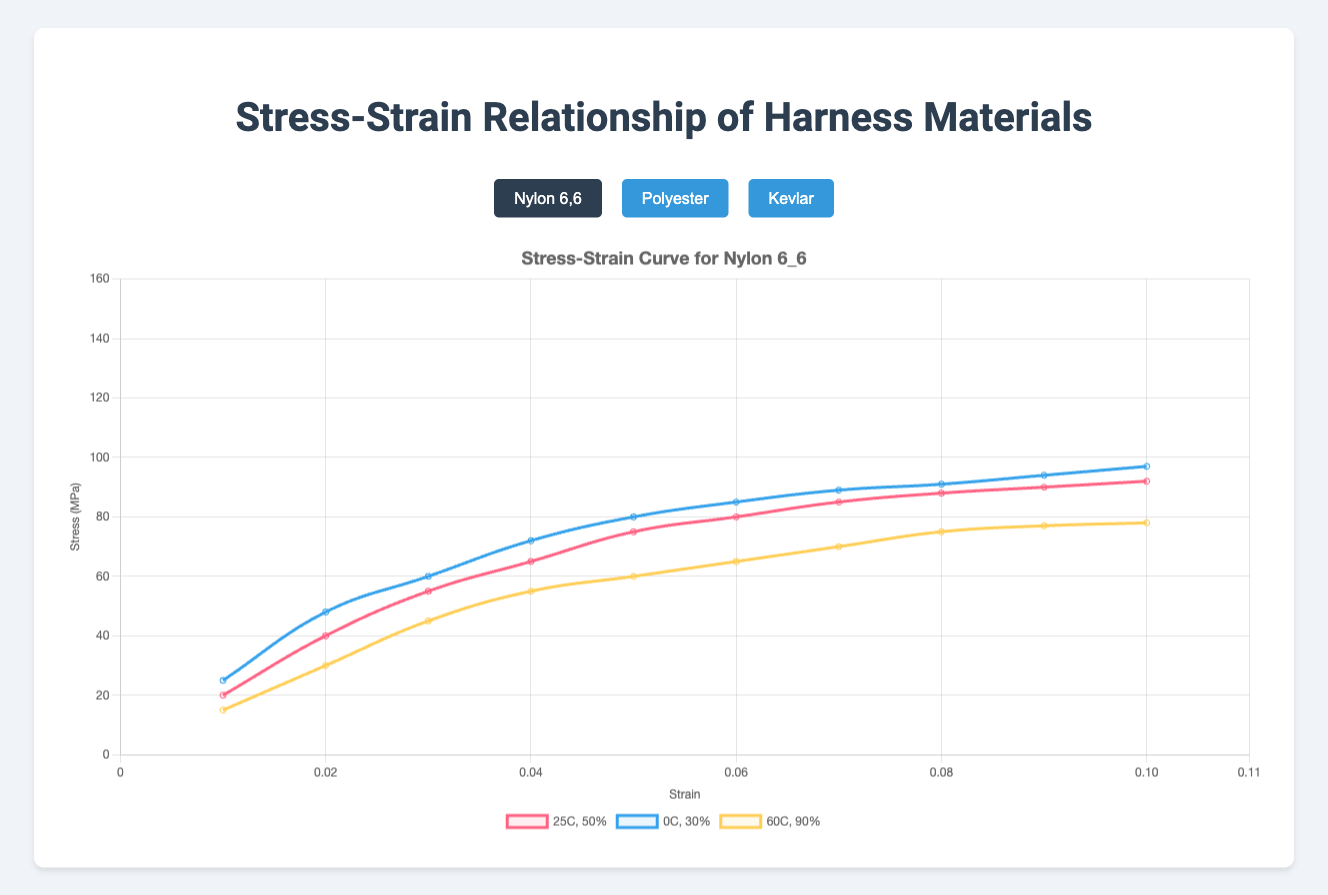What material has the highest stress value at a strain of 0.05? At a strain of 0.05, the materials show the following stress values: Nylon 6,6 (25C, 50%): 75, Nylon 6,6 (0C, 30%): 80, Nylon 6,6 (60C, 90%): 60; Polyester (25C, 50%): 90, Polyester (0C, 30%): 100, Polyester (60C, 90%): 80; Kevlar (25C, 50%): 110, Kevlar (0C, 30%): 140, Kevlar (60C, 90%): 110. The highest value is 140 for Kevlar at 0C and 30% humidity.
Answer: Kevlar at 0C and 30% humidity Which material's stress values show the least variation across different conditions at a strain of 0.10? For a strain of 0.10, the stress values are: Nylon 6,6: (92, 97, 78); Polyester: (99, 117, 93); Kevlar: (123, 155, 122). The material with the least variation (difference between maximum and minimum stress values) is Nylon 6,6, with a range of 97 - 78 = 19.
Answer: Nylon 6,6 Which material shows the highest initial stress value at a strain of 0.01? At a strain of 0.01, the initial stress values are: Nylon 6,6 (25C, 50%): 20, Nylon 6,6 (0C, 30%): 25, Nylon 6,6 (60C, 90%): 15; Polyester (25C, 50%): 30, Polyester (0C, 30%): 35, Polyester (60C, 90%): 25; Kevlar (25C, 50%): 40, Kevlar (0C, 30%): 50, Kevlar (60C, 90%): 35. The highest value is 50 for Kevlar at 0C and 30% humidity.
Answer: Kevlar at 0C and 30% humidity Compare the stress values for Nylon 6,6 at 0C and 25C at a strain of 0.06, which shows higher stress? At a strain of 0.06, the stress values for Nylon 6,6 are: 0C, 30%: 85 and 25C, 50%: 80. The higher stress value is at 0C, 30%.
Answer: 0C, 30% How does increasing the temperature from 0C to 60C affect the stress at a strain of 0.08 for Nylon 6,6? For Nylon 6,6 at a strain of 0.08, the stress values are: 0C, 30%: 91 and 60C, 90%: 75. Increasing the temperature from 0C to 60C decreases the stress from 91 to 75.
Answer: Decreases For Kevlar, at what temperature and humidity condition does it reach its maximum stress at a strain of 0.02? At a strain of 0.02, the stress values for Kevlar are: 25C, 50%: 70, 0C, 30%: 85, 60C, 90%: 65. The maximum stress of 85 occurs at 0C, 30%.
Answer: 0C, 30% What is the average stress for Polyester at a strain of 0.07 across all conditions? At a strain of 0.07, the stress values for Polyester are: 25C, 50%: 95, 0C, 30%: 110, 60C, 90%: 88. The average stress is (95 + 110 + 88) / 3 = 97.67.
Answer: 97.67 What is the difference in stress values for Kevlar between 25C and 60C at a strain of 0.04? At a strain of 0.04, the stress values for Kevlar are: 25C, 50%: 105 and 60C, 90%: 100. The difference is 105 - 100 = 5.
Answer: 5 